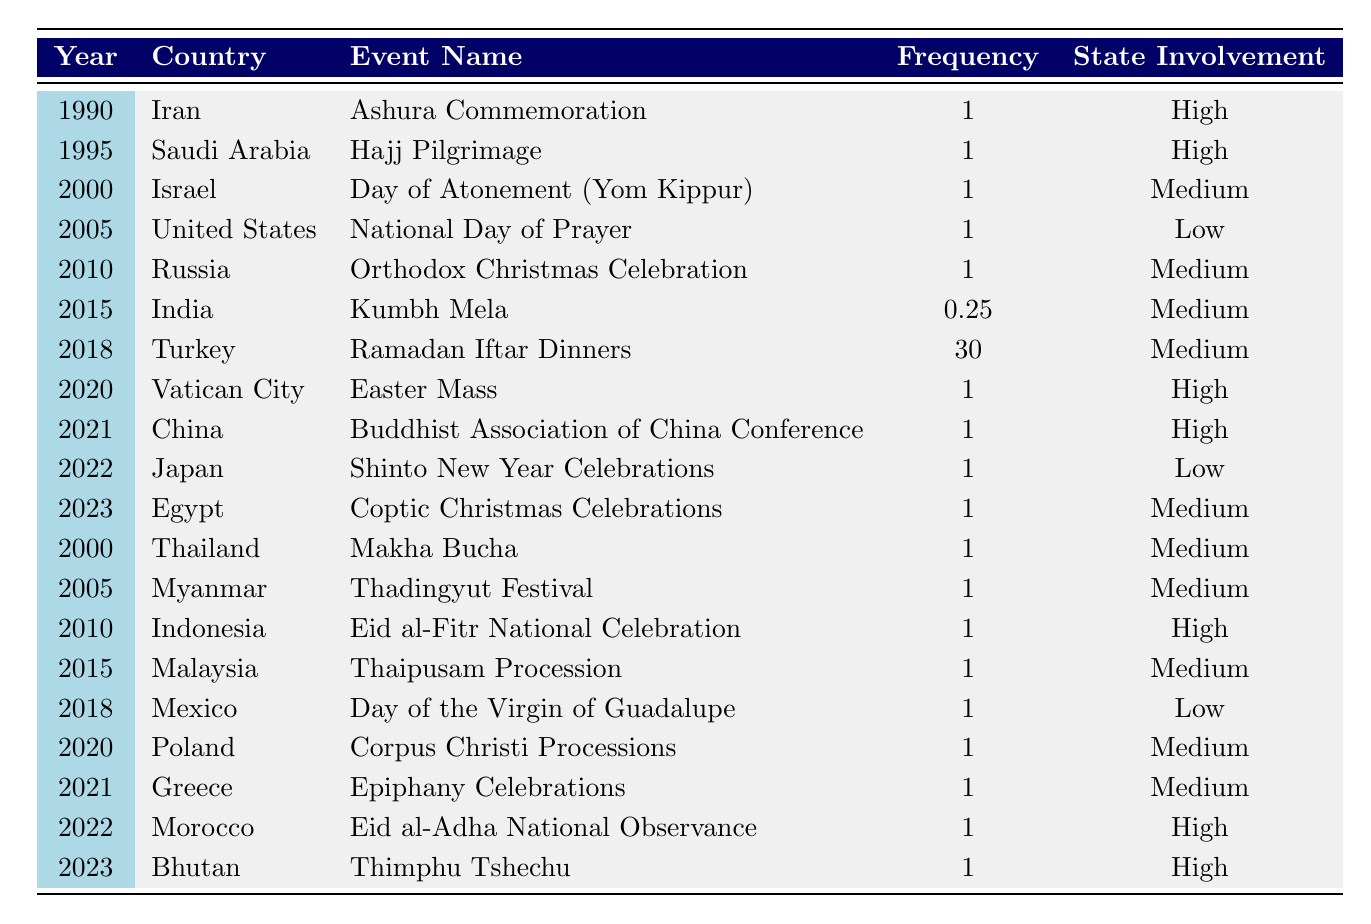What is the most frequent state-sponsored religious event in the table? The table shows Turkey's Ramadan Iftar Dinners with a frequency of 30 events per year, which is higher than any other event listed.
Answer: Ramadan Iftar Dinners How many countries have high state involvement in religious events according to the table? The table indicates that there are seven entries with a "High" state involvement level: Iran, Saudi Arabia, Vatican City, China, Indonesia, Morocco, and Bhutan.
Answer: 7 What is the frequency of the Kumbh Mela event in India? The table lists the Kumbh Mela with a frequency of 0.25 events per year in India.
Answer: 0.25 Which country had its national day of prayer listed, and what was the level of state involvement? The United States had the National Day of Prayer listed with a state involvement level of "Low."
Answer: United States, Low Which country had the lowest frequency of an event and what was that event? India had the lowest frequency with the Kumbh Mela at 0.25 per year.
Answer: Kumbh Mela Which two countries have the same frequency of 1 event per year and medium state involvement? The countries Israel and Myanmar both have a frequency of 1 per year and a medium state involvement level for their respective events.
Answer: Israel and Myanmar In what year was the last occurrence of a "High" state involvement event recorded? The last occurrence of a "High" state involvement event in the table is in 2023 for Bhutan's Thimphu Tshechu.
Answer: 2023 Are there any countries listed that have the same frequency but different state involvement levels? Yes, Turkey has a frequency of 30 and medium involvement, while many others like Israel, Myanmar, and others have 1 and medium involvement.
Answer: Yes What is the total frequency of state-sponsored religious events listed for 2010? The events for 2010 are Orthodox Christmas Celebration (1) in Russia and Eid al-Fitr National Celebration (1) in Indonesia, leading to a total frequency of 2.
Answer: 2 Which two countries are associated with the same type of religious event in the same year? Countries like Thailand and Myanmar both celebrate an event on "Makha Bucha" and "Thadingyut Festival," however, they do not occur in the same year.
Answer: No 